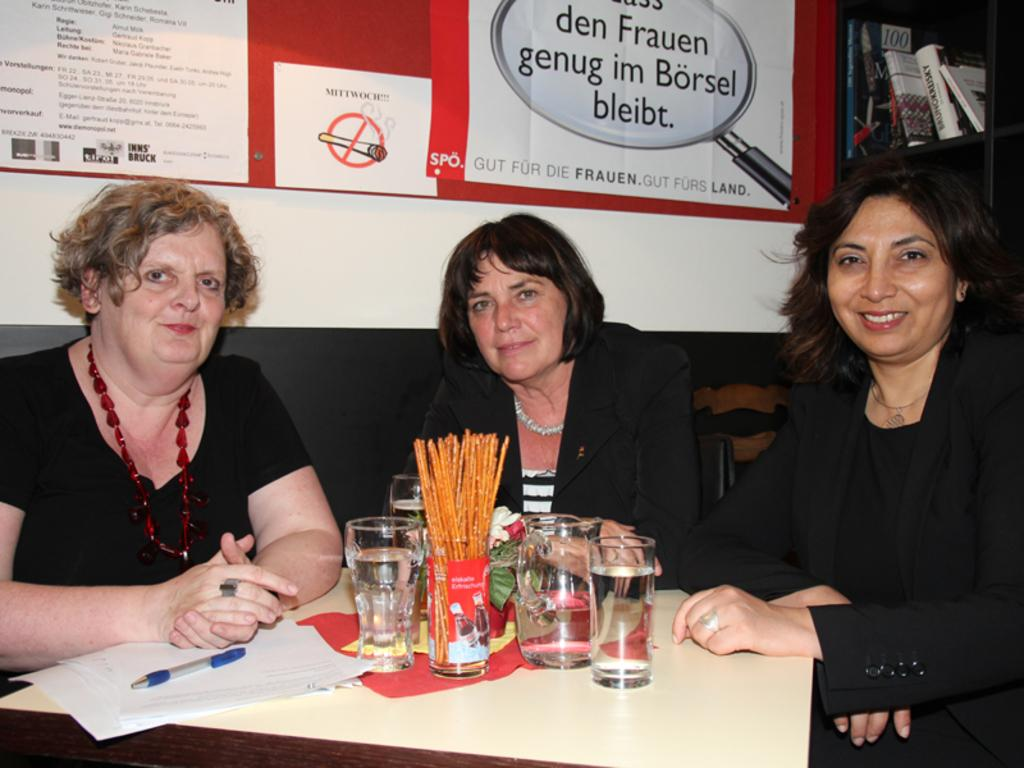How many women are sitting on the chair in the image? There are three women sitting on a chair in the image. What objects can be seen on the table? There is a container, glasses, a paper, and a pen on the table. What is hanging on the wall? There is a banner on the wall. What can be found on the rack in the image? The rack is filled with books. How does the wind affect the women sitting on the chair in the image? There is no wind present in the image, so its effect on the women cannot be determined. What part of the chair are the women sitting on? The provided facts do not specify which part of the chair the women are sitting on. 